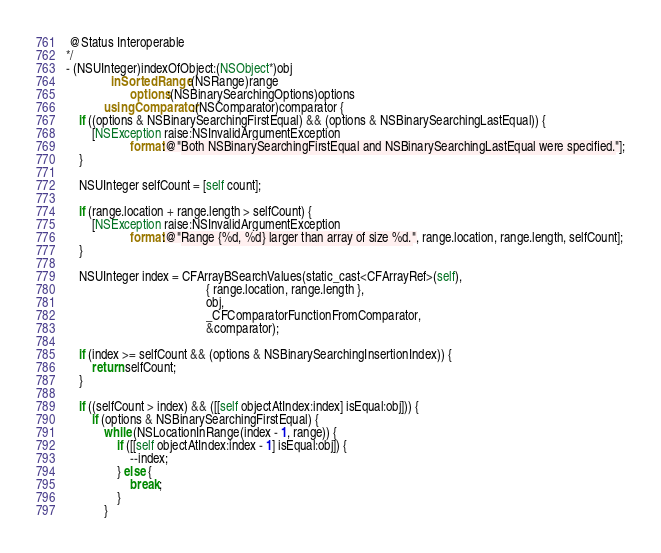<code> <loc_0><loc_0><loc_500><loc_500><_ObjectiveC_> @Status Interoperable
*/
- (NSUInteger)indexOfObject:(NSObject*)obj
              inSortedRange:(NSRange)range
                    options:(NSBinarySearchingOptions)options
            usingComparator:(NSComparator)comparator {
    if ((options & NSBinarySearchingFirstEqual) && (options & NSBinarySearchingLastEqual)) {
        [NSException raise:NSInvalidArgumentException
                    format:@"Both NSBinarySearchingFirstEqual and NSBinarySearchingLastEqual were specified."];
    }

    NSUInteger selfCount = [self count];

    if (range.location + range.length > selfCount) {
        [NSException raise:NSInvalidArgumentException
                    format:@"Range {%d, %d} larger than array of size %d.", range.location, range.length, selfCount];
    }

    NSUInteger index = CFArrayBSearchValues(static_cast<CFArrayRef>(self),
                                            { range.location, range.length },
                                            obj,
                                            _CFComparatorFunctionFromComparator,
                                            &comparator);

    if (index >= selfCount && (options & NSBinarySearchingInsertionIndex)) {
        return selfCount;
    }

    if ((selfCount > index) && ([[self objectAtIndex:index] isEqual:obj])) {
        if (options & NSBinarySearchingFirstEqual) {
            while (NSLocationInRange(index - 1, range)) {
                if ([[self objectAtIndex:index - 1] isEqual:obj]) {
                    --index;
                } else {
                    break;
                }
            }</code> 